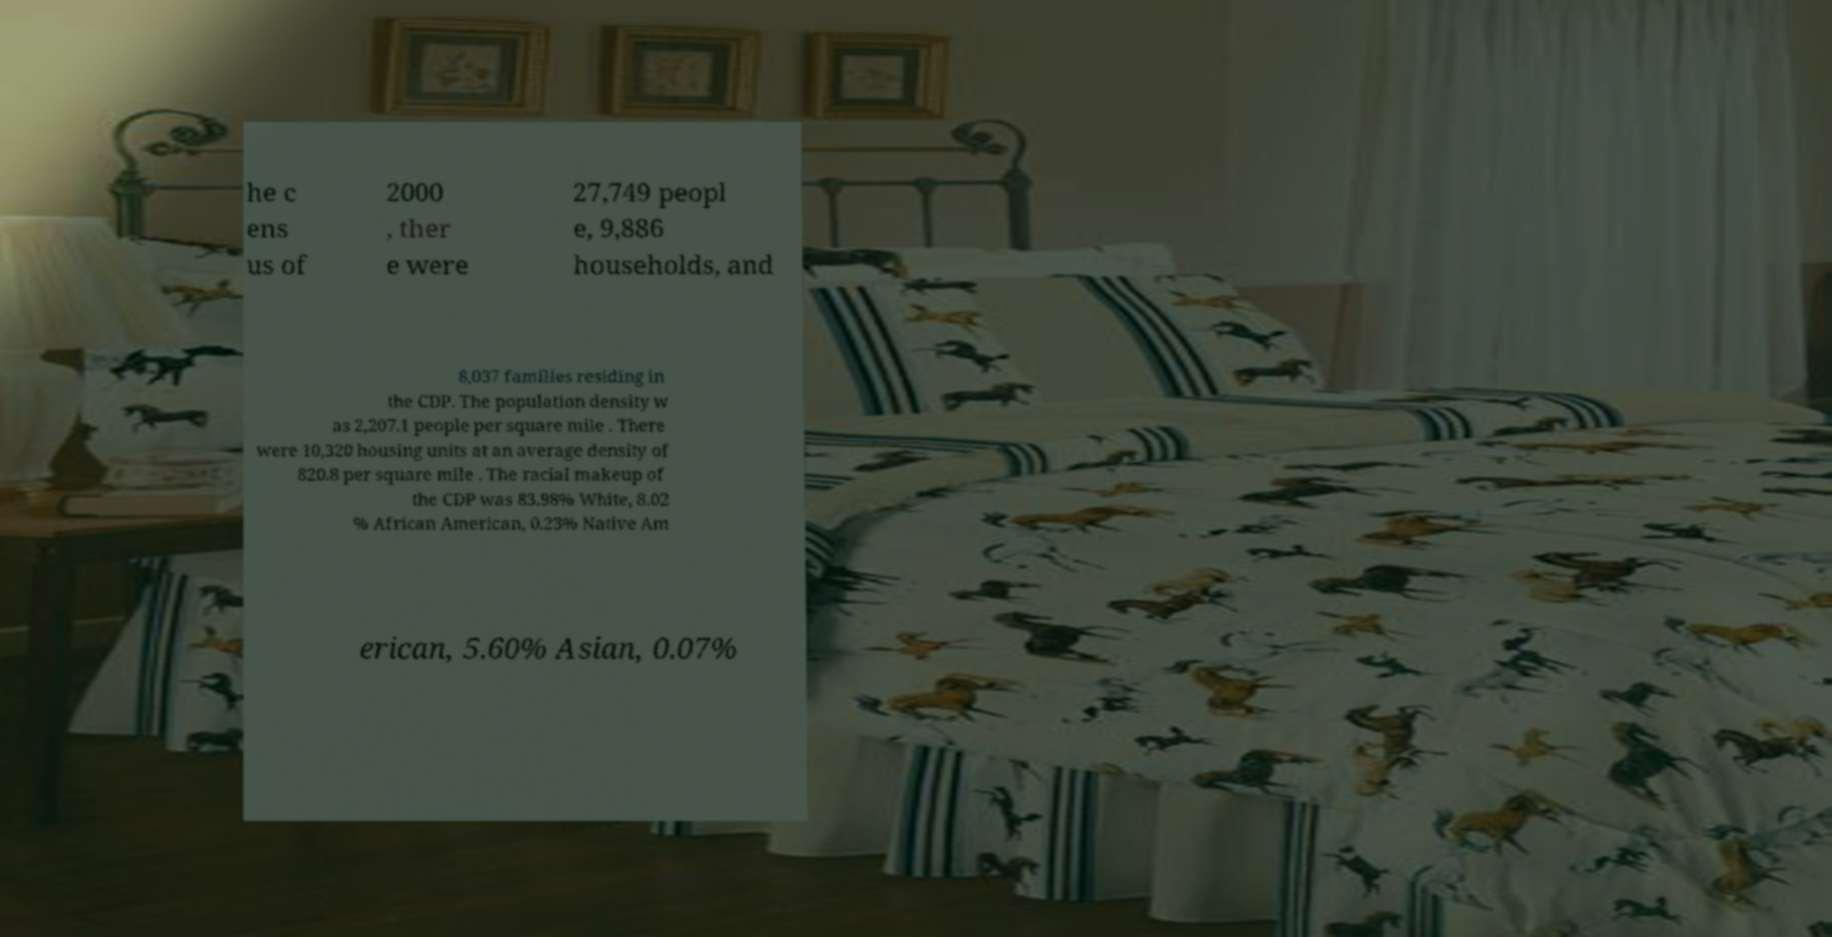What messages or text are displayed in this image? I need them in a readable, typed format. he c ens us of 2000 , ther e were 27,749 peopl e, 9,886 households, and 8,037 families residing in the CDP. The population density w as 2,207.1 people per square mile . There were 10,320 housing units at an average density of 820.8 per square mile . The racial makeup of the CDP was 83.98% White, 8.02 % African American, 0.23% Native Am erican, 5.60% Asian, 0.07% 